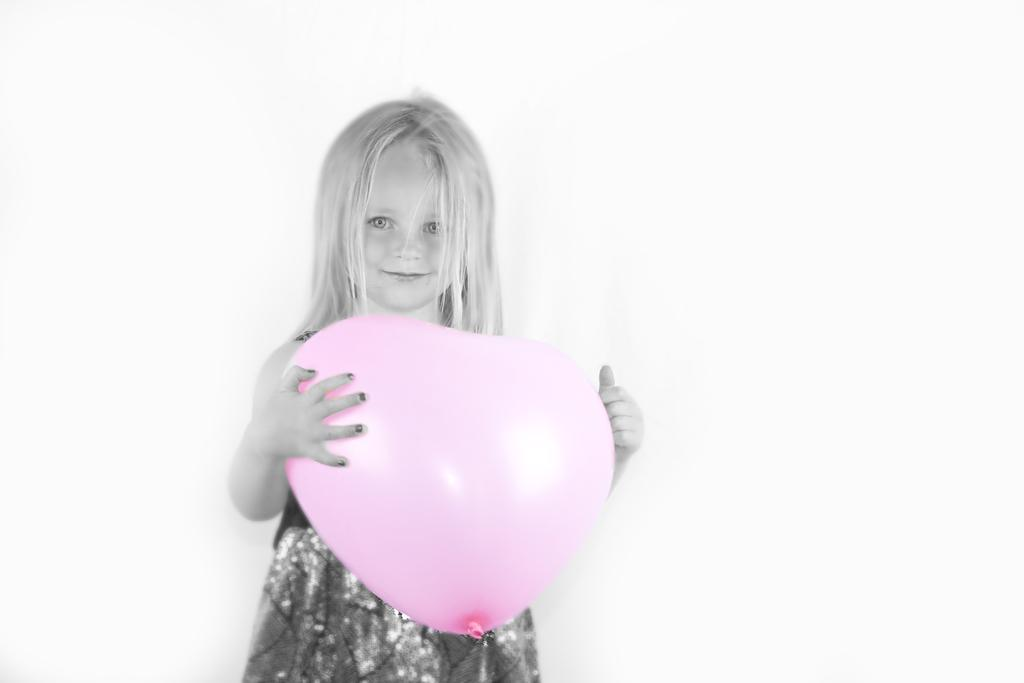Who is the main subject in the image? There is a girl in the image. What is the girl holding in the image? The girl is holding a balloon. What color is the background of the image? The background of the image is white. Where might the image have been taken? The image may have been taken in a house. What channel is the girl watching on the television in the image? There is no television present in the image, so it is not possible to determine what channel the girl might be watching. 